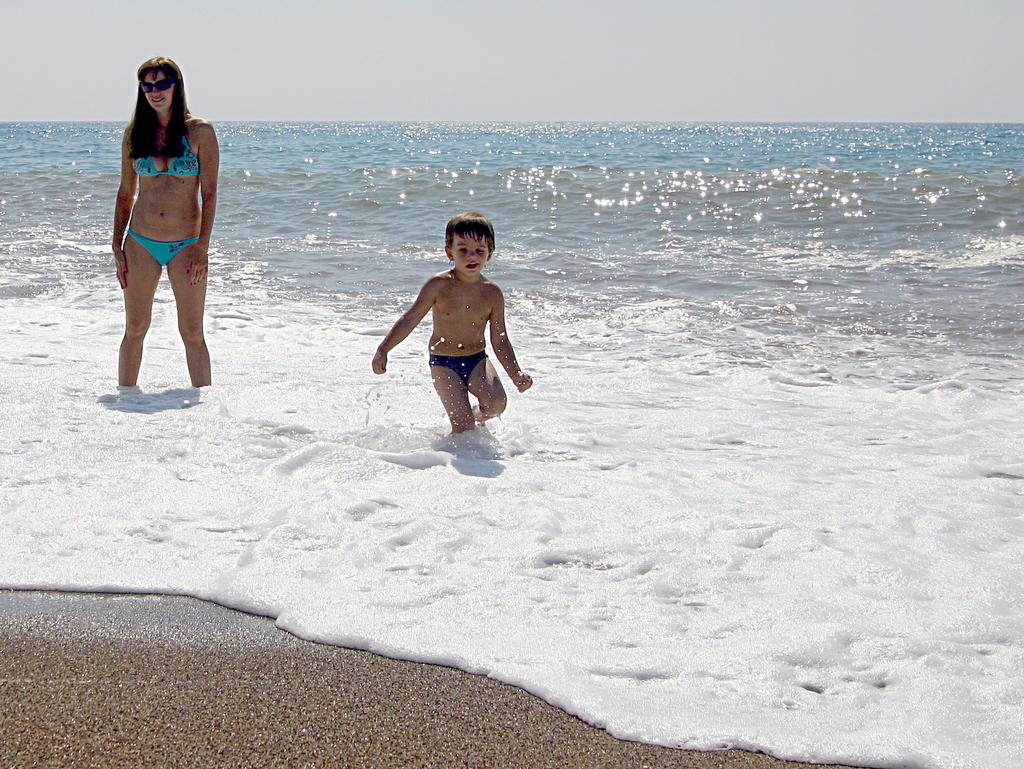What are the persons in the image doing? The persons in the image are standing in the water. What can be seen in the background of the image? There is an ocean visible in the background of the image. Can you see a giraffe swimming in the ocean in the image? No, there is no giraffe present in the image, and the ocean is in the background, not the foreground where the persons are standing. 